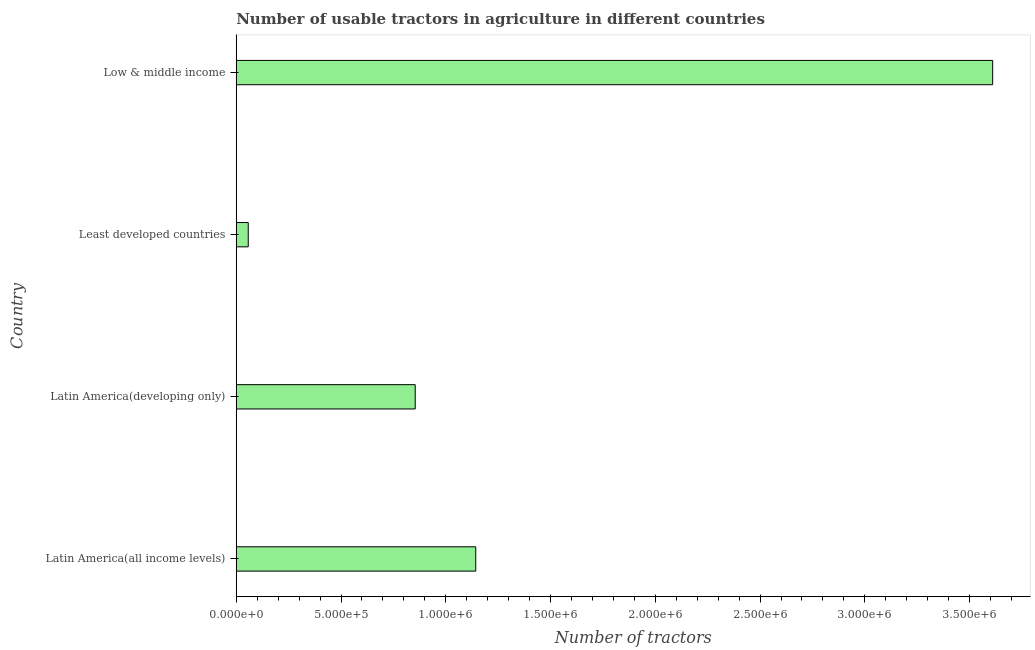What is the title of the graph?
Offer a very short reply. Number of usable tractors in agriculture in different countries. What is the label or title of the X-axis?
Make the answer very short. Number of tractors. What is the number of tractors in Latin America(developing only)?
Ensure brevity in your answer.  8.54e+05. Across all countries, what is the maximum number of tractors?
Give a very brief answer. 3.61e+06. Across all countries, what is the minimum number of tractors?
Provide a succinct answer. 5.73e+04. In which country was the number of tractors minimum?
Offer a terse response. Least developed countries. What is the sum of the number of tractors?
Keep it short and to the point. 5.66e+06. What is the difference between the number of tractors in Latin America(developing only) and Low & middle income?
Offer a terse response. -2.76e+06. What is the average number of tractors per country?
Make the answer very short. 1.42e+06. What is the median number of tractors?
Your answer should be compact. 9.99e+05. In how many countries, is the number of tractors greater than 800000 ?
Make the answer very short. 3. What is the ratio of the number of tractors in Least developed countries to that in Low & middle income?
Offer a terse response. 0.02. Is the number of tractors in Least developed countries less than that in Low & middle income?
Offer a very short reply. Yes. Is the difference between the number of tractors in Latin America(developing only) and Low & middle income greater than the difference between any two countries?
Ensure brevity in your answer.  No. What is the difference between the highest and the second highest number of tractors?
Ensure brevity in your answer.  2.47e+06. What is the difference between the highest and the lowest number of tractors?
Ensure brevity in your answer.  3.55e+06. In how many countries, is the number of tractors greater than the average number of tractors taken over all countries?
Make the answer very short. 1. How many bars are there?
Your response must be concise. 4. How many countries are there in the graph?
Your answer should be very brief. 4. What is the difference between two consecutive major ticks on the X-axis?
Keep it short and to the point. 5.00e+05. What is the Number of tractors of Latin America(all income levels)?
Your response must be concise. 1.14e+06. What is the Number of tractors in Latin America(developing only)?
Offer a terse response. 8.54e+05. What is the Number of tractors of Least developed countries?
Provide a succinct answer. 5.73e+04. What is the Number of tractors in Low & middle income?
Keep it short and to the point. 3.61e+06. What is the difference between the Number of tractors in Latin America(all income levels) and Latin America(developing only)?
Make the answer very short. 2.89e+05. What is the difference between the Number of tractors in Latin America(all income levels) and Least developed countries?
Offer a terse response. 1.09e+06. What is the difference between the Number of tractors in Latin America(all income levels) and Low & middle income?
Your answer should be very brief. -2.47e+06. What is the difference between the Number of tractors in Latin America(developing only) and Least developed countries?
Ensure brevity in your answer.  7.97e+05. What is the difference between the Number of tractors in Latin America(developing only) and Low & middle income?
Offer a terse response. -2.76e+06. What is the difference between the Number of tractors in Least developed countries and Low & middle income?
Your answer should be very brief. -3.55e+06. What is the ratio of the Number of tractors in Latin America(all income levels) to that in Latin America(developing only)?
Keep it short and to the point. 1.34. What is the ratio of the Number of tractors in Latin America(all income levels) to that in Least developed countries?
Keep it short and to the point. 19.96. What is the ratio of the Number of tractors in Latin America(all income levels) to that in Low & middle income?
Keep it short and to the point. 0.32. What is the ratio of the Number of tractors in Latin America(developing only) to that in Least developed countries?
Your response must be concise. 14.91. What is the ratio of the Number of tractors in Latin America(developing only) to that in Low & middle income?
Give a very brief answer. 0.24. What is the ratio of the Number of tractors in Least developed countries to that in Low & middle income?
Make the answer very short. 0.02. 